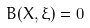Convert formula to latex. <formula><loc_0><loc_0><loc_500><loc_500>B ( X , \xi ) = 0</formula> 